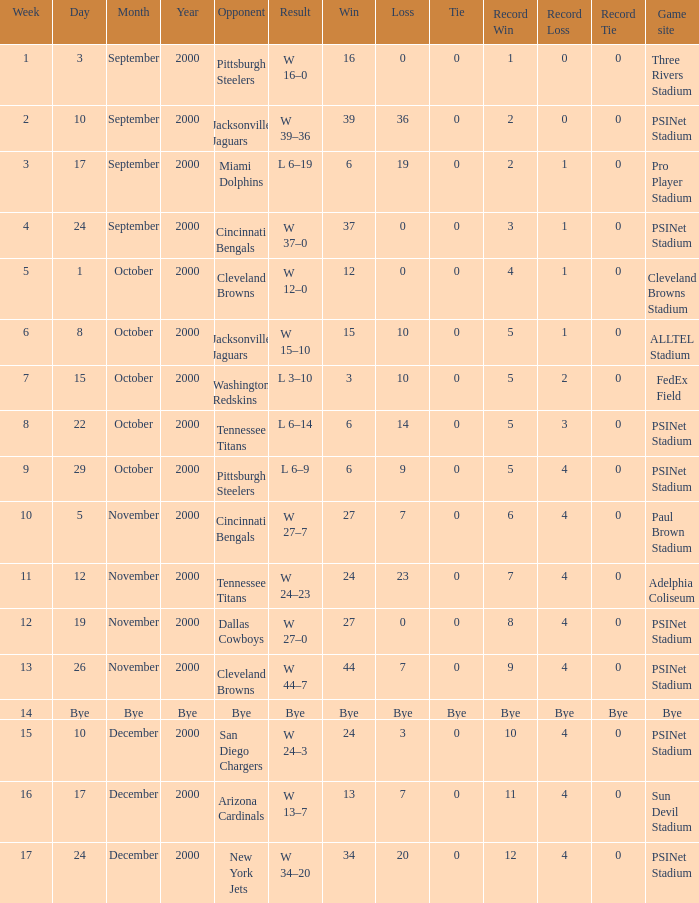Parse the table in full. {'header': ['Week', 'Day', 'Month', 'Year', 'Opponent', 'Result', 'Win', 'Loss', 'Tie', 'Record Win', 'Record Loss', 'Record Tie', 'Game site'], 'rows': [['1', '3', 'September', '2000', 'Pittsburgh Steelers', 'W 16–0', '16', '0', '0', '1', '0', '0', 'Three Rivers Stadium'], ['2', '10', 'September', '2000', 'Jacksonville Jaguars', 'W 39–36', '39', '36', '0', '2', '0', '0', 'PSINet Stadium'], ['3', '17', 'September', '2000', 'Miami Dolphins', 'L 6–19', '6', '19', '0', '2', '1', '0', 'Pro Player Stadium'], ['4', '24', 'September', '2000', 'Cincinnati Bengals', 'W 37–0', '37', '0', '0', '3', '1', '0', 'PSINet Stadium'], ['5', '1', 'October', '2000', 'Cleveland Browns', 'W 12–0', '12', '0', '0', '4', '1', '0', 'Cleveland Browns Stadium'], ['6', '8', 'October', '2000', 'Jacksonville Jaguars', 'W 15–10', '15', '10', '0', '5', '1', '0', 'ALLTEL Stadium'], ['7', '15', 'October', '2000', 'Washington Redskins', 'L 3–10', '3', '10', '0', '5', '2', '0', 'FedEx Field'], ['8', '22', 'October', '2000', 'Tennessee Titans', 'L 6–14', '6', '14', '0', '5', '3', '0', 'PSINet Stadium'], ['9', '29', 'October', '2000', 'Pittsburgh Steelers', 'L 6–9', '6', '9', '0', '5', '4', '0', 'PSINet Stadium'], ['10', '5', 'November', '2000', 'Cincinnati Bengals', 'W 27–7', '27', '7', '0', '6', '4', '0', 'Paul Brown Stadium'], ['11', '12', 'November', '2000', 'Tennessee Titans', 'W 24–23', '24', '23', '0', '7', '4', '0', 'Adelphia Coliseum'], ['12', '19', 'November', '2000', 'Dallas Cowboys', 'W 27–0', '27', '0', '0', '8', '4', '0', 'PSINet Stadium'], ['13', '26', 'November', '2000', 'Cleveland Browns', 'W 44–7', '44', '7', '0', '9', '4', '0', 'PSINet Stadium'], ['14', 'Bye', 'Bye', 'Bye', 'Bye', 'Bye', 'Bye', 'Bye', 'Bye', 'Bye', 'Bye', 'Bye', 'Bye'], ['15', '10', 'December', '2000', 'San Diego Chargers', 'W 24–3', '24', '3', '0', '10', '4', '0', 'PSINet Stadium'], ['16', '17', 'December', '2000', 'Arizona Cardinals', 'W 13–7', '13', '7', '0', '11', '4', '0', 'Sun Devil Stadium'], ['17', '24', 'December', '2000', 'New York Jets', 'W 34–20', '34', '20', '0', '12', '4', '0', 'PSINet Stadium']]} What game site has a result of bye? Bye. 